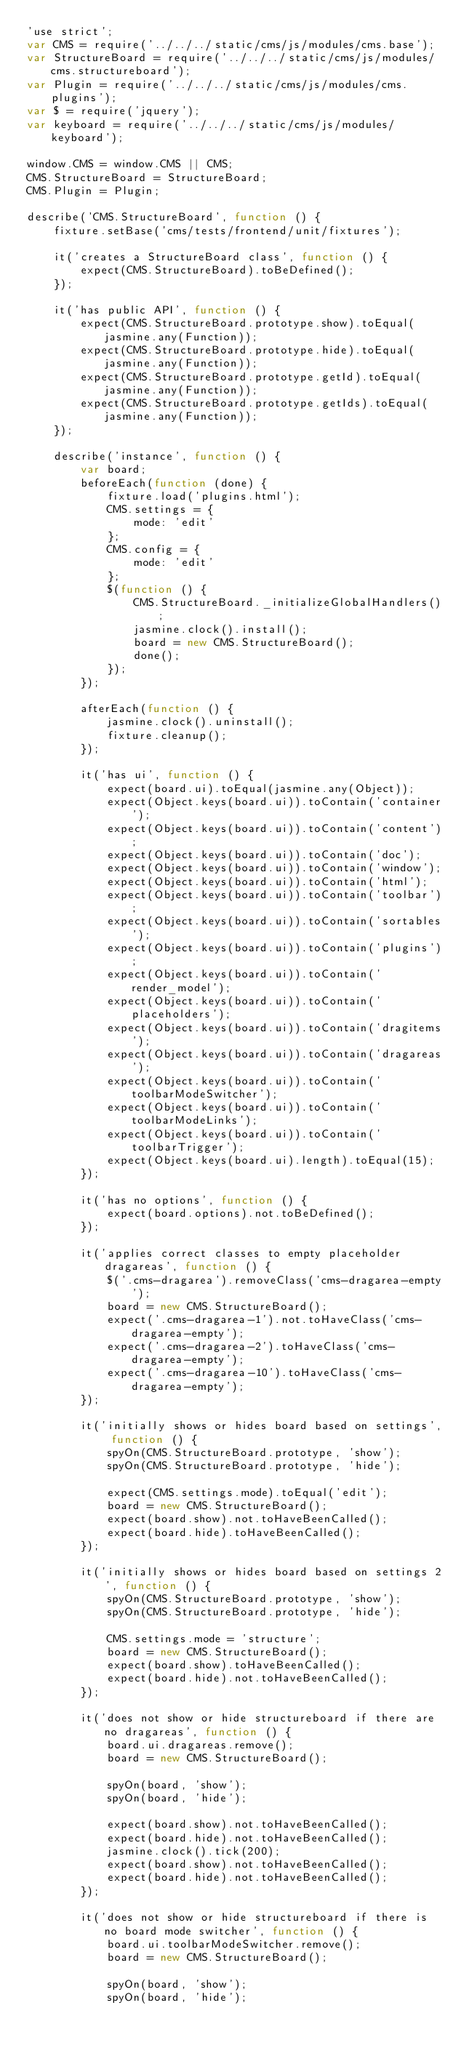Convert code to text. <code><loc_0><loc_0><loc_500><loc_500><_JavaScript_>'use strict';
var CMS = require('../../../static/cms/js/modules/cms.base');
var StructureBoard = require('../../../static/cms/js/modules/cms.structureboard');
var Plugin = require('../../../static/cms/js/modules/cms.plugins');
var $ = require('jquery');
var keyboard = require('../../../static/cms/js/modules/keyboard');

window.CMS = window.CMS || CMS;
CMS.StructureBoard = StructureBoard;
CMS.Plugin = Plugin;

describe('CMS.StructureBoard', function () {
    fixture.setBase('cms/tests/frontend/unit/fixtures');

    it('creates a StructureBoard class', function () {
        expect(CMS.StructureBoard).toBeDefined();
    });

    it('has public API', function () {
        expect(CMS.StructureBoard.prototype.show).toEqual(jasmine.any(Function));
        expect(CMS.StructureBoard.prototype.hide).toEqual(jasmine.any(Function));
        expect(CMS.StructureBoard.prototype.getId).toEqual(jasmine.any(Function));
        expect(CMS.StructureBoard.prototype.getIds).toEqual(jasmine.any(Function));
    });

    describe('instance', function () {
        var board;
        beforeEach(function (done) {
            fixture.load('plugins.html');
            CMS.settings = {
                mode: 'edit'
            };
            CMS.config = {
                mode: 'edit'
            };
            $(function () {
                CMS.StructureBoard._initializeGlobalHandlers();
                jasmine.clock().install();
                board = new CMS.StructureBoard();
                done();
            });
        });

        afterEach(function () {
            jasmine.clock().uninstall();
            fixture.cleanup();
        });

        it('has ui', function () {
            expect(board.ui).toEqual(jasmine.any(Object));
            expect(Object.keys(board.ui)).toContain('container');
            expect(Object.keys(board.ui)).toContain('content');
            expect(Object.keys(board.ui)).toContain('doc');
            expect(Object.keys(board.ui)).toContain('window');
            expect(Object.keys(board.ui)).toContain('html');
            expect(Object.keys(board.ui)).toContain('toolbar');
            expect(Object.keys(board.ui)).toContain('sortables');
            expect(Object.keys(board.ui)).toContain('plugins');
            expect(Object.keys(board.ui)).toContain('render_model');
            expect(Object.keys(board.ui)).toContain('placeholders');
            expect(Object.keys(board.ui)).toContain('dragitems');
            expect(Object.keys(board.ui)).toContain('dragareas');
            expect(Object.keys(board.ui)).toContain('toolbarModeSwitcher');
            expect(Object.keys(board.ui)).toContain('toolbarModeLinks');
            expect(Object.keys(board.ui)).toContain('toolbarTrigger');
            expect(Object.keys(board.ui).length).toEqual(15);
        });

        it('has no options', function () {
            expect(board.options).not.toBeDefined();
        });

        it('applies correct classes to empty placeholder dragareas', function () {
            $('.cms-dragarea').removeClass('cms-dragarea-empty');
            board = new CMS.StructureBoard();
            expect('.cms-dragarea-1').not.toHaveClass('cms-dragarea-empty');
            expect('.cms-dragarea-2').toHaveClass('cms-dragarea-empty');
            expect('.cms-dragarea-10').toHaveClass('cms-dragarea-empty');
        });

        it('initially shows or hides board based on settings', function () {
            spyOn(CMS.StructureBoard.prototype, 'show');
            spyOn(CMS.StructureBoard.prototype, 'hide');

            expect(CMS.settings.mode).toEqual('edit');
            board = new CMS.StructureBoard();
            expect(board.show).not.toHaveBeenCalled();
            expect(board.hide).toHaveBeenCalled();
        });

        it('initially shows or hides board based on settings 2', function () {
            spyOn(CMS.StructureBoard.prototype, 'show');
            spyOn(CMS.StructureBoard.prototype, 'hide');

            CMS.settings.mode = 'structure';
            board = new CMS.StructureBoard();
            expect(board.show).toHaveBeenCalled();
            expect(board.hide).not.toHaveBeenCalled();
        });

        it('does not show or hide structureboard if there are no dragareas', function () {
            board.ui.dragareas.remove();
            board = new CMS.StructureBoard();

            spyOn(board, 'show');
            spyOn(board, 'hide');

            expect(board.show).not.toHaveBeenCalled();
            expect(board.hide).not.toHaveBeenCalled();
            jasmine.clock().tick(200);
            expect(board.show).not.toHaveBeenCalled();
            expect(board.hide).not.toHaveBeenCalled();
        });

        it('does not show or hide structureboard if there is no board mode switcher', function () {
            board.ui.toolbarModeSwitcher.remove();
            board = new CMS.StructureBoard();

            spyOn(board, 'show');
            spyOn(board, 'hide');
</code> 